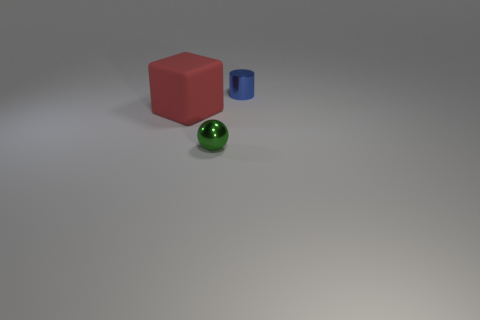Add 3 cylinders. How many objects exist? 6 Subtract all cylinders. How many objects are left? 2 Add 3 large red objects. How many large red objects are left? 4 Add 1 green objects. How many green objects exist? 2 Subtract 0 blue spheres. How many objects are left? 3 Subtract all metal cubes. Subtract all blocks. How many objects are left? 2 